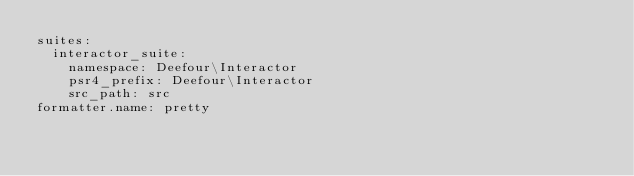Convert code to text. <code><loc_0><loc_0><loc_500><loc_500><_YAML_>suites:
  interactor_suite:
    namespace: Deefour\Interactor
    psr4_prefix: Deefour\Interactor
    src_path: src
formatter.name: pretty
</code> 